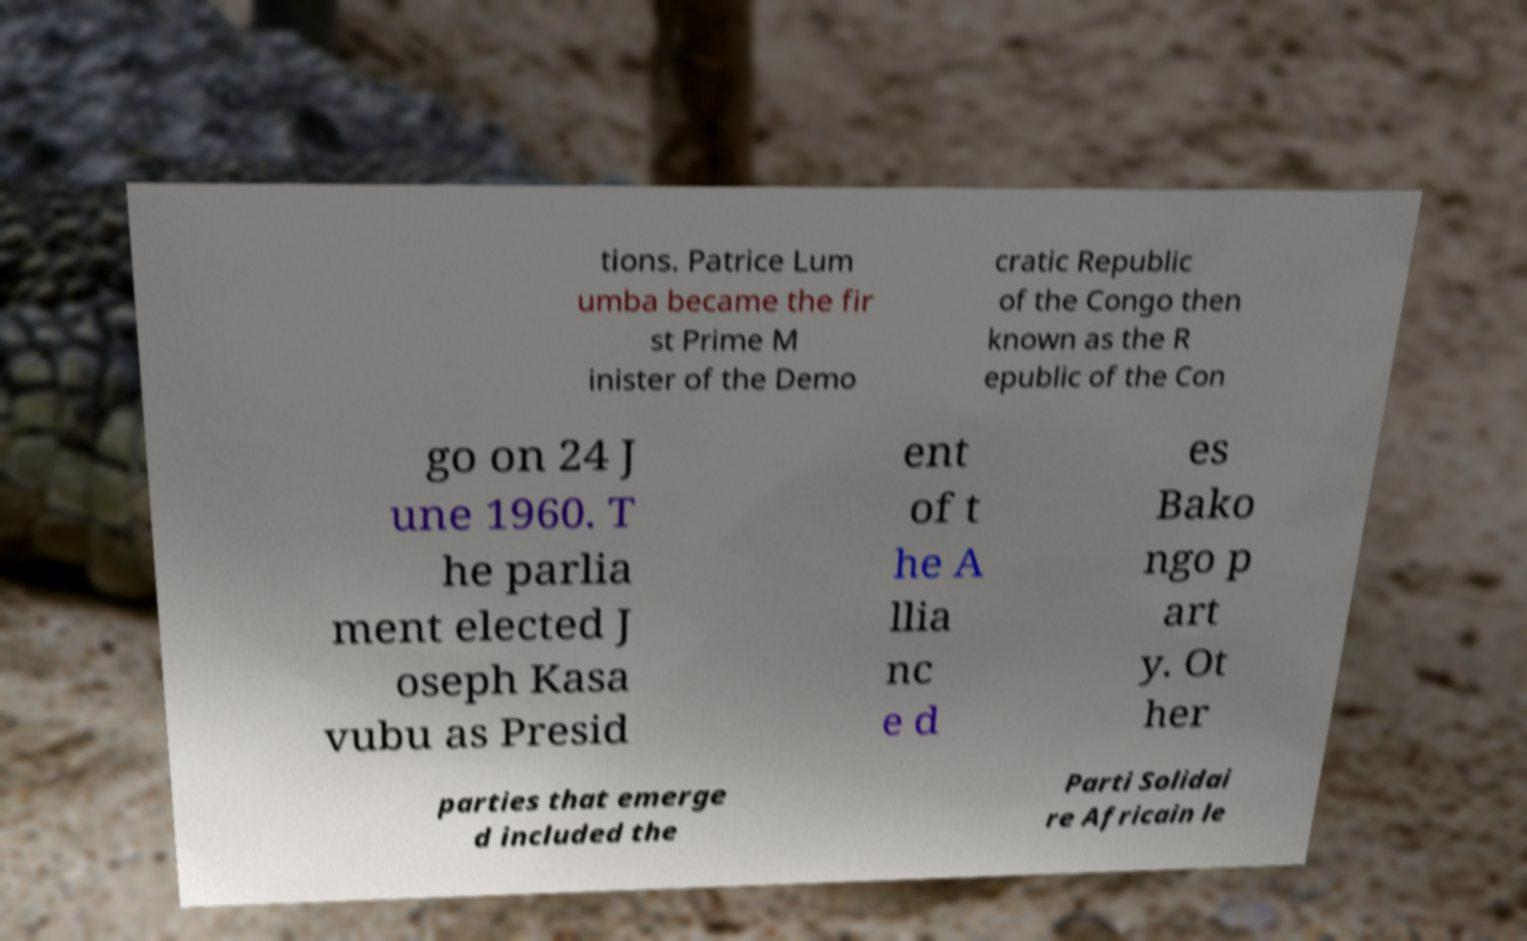Could you assist in decoding the text presented in this image and type it out clearly? tions. Patrice Lum umba became the fir st Prime M inister of the Demo cratic Republic of the Congo then known as the R epublic of the Con go on 24 J une 1960. T he parlia ment elected J oseph Kasa vubu as Presid ent of t he A llia nc e d es Bako ngo p art y. Ot her parties that emerge d included the Parti Solidai re Africain le 